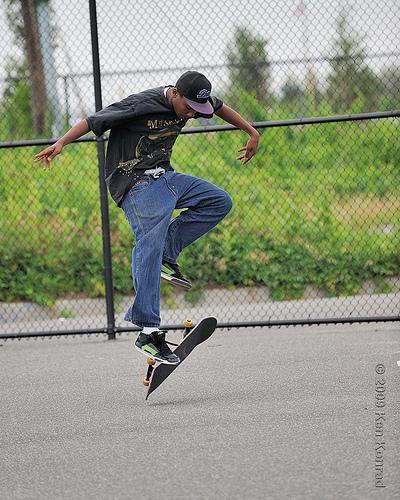Question: what sport is shown?
Choices:
A. Skiing.
B. Skateboarding.
C. Biking.
D. Surfing.
Answer with the letter. Answer: B Question: what color are the wheels on the board?
Choices:
A. Black.
B. Brown.
C. Yellow.
D. Grey.
Answer with the letter. Answer: C Question: where was this shot taken?
Choices:
A. Park.
B. Basketball game.
C. Parking lot.
D. Carnival.
Answer with the letter. Answer: C Question: what is this person riding?
Choices:
A. Surf board.
B. Skateboard.
C. Skiis.
D. Scooter.
Answer with the letter. Answer: B Question: who took the photo?
Choices:
A. Ken konrad.
B. Jeff Gordan.
C. George Bush.
D. Kelly Clarckson.
Answer with the letter. Answer: A 